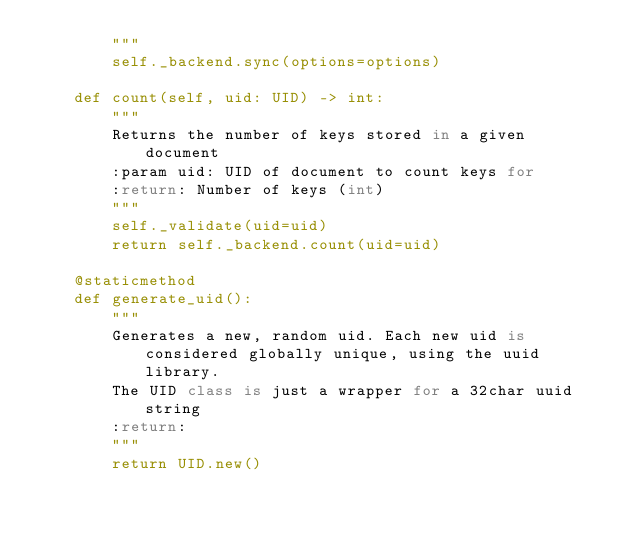Convert code to text. <code><loc_0><loc_0><loc_500><loc_500><_Python_>        """
        self._backend.sync(options=options)

    def count(self, uid: UID) -> int:
        """
        Returns the number of keys stored in a given document
        :param uid: UID of document to count keys for
        :return: Number of keys (int)
        """
        self._validate(uid=uid)
        return self._backend.count(uid=uid)

    @staticmethod
    def generate_uid():
        """
        Generates a new, random uid. Each new uid is considered globally unique, using the uuid library.
        The UID class is just a wrapper for a 32char uuid string
        :return:
        """
        return UID.new()
</code> 